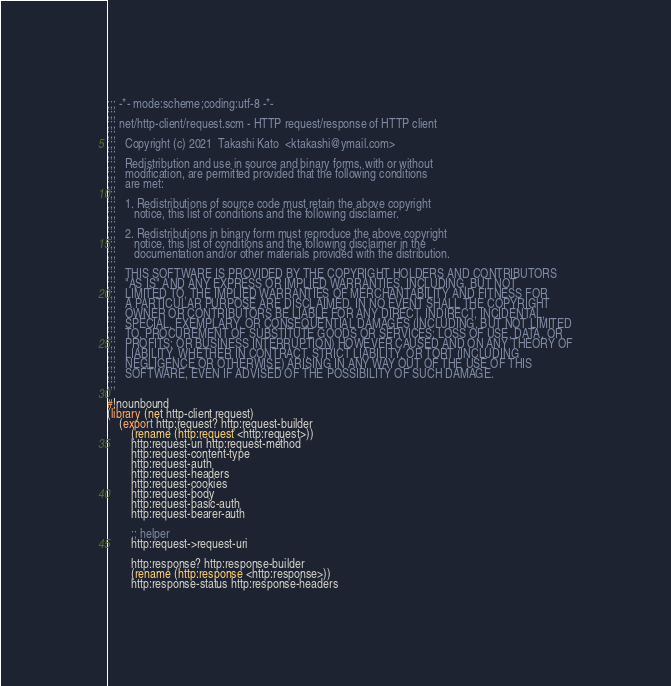<code> <loc_0><loc_0><loc_500><loc_500><_Scheme_>;;; -*- mode:scheme;coding:utf-8 -*-
;;;
;;; net/http-client/request.scm - HTTP request/response of HTTP client
;;;  
;;;   Copyright (c) 2021  Takashi Kato  <ktakashi@ymail.com>
;;;   
;;;   Redistribution and use in source and binary forms, with or without
;;;   modification, are permitted provided that the following conditions
;;;   are met:
;;;   
;;;   1. Redistributions of source code must retain the above copyright
;;;      notice, this list of conditions and the following disclaimer.
;;;  
;;;   2. Redistributions in binary form must reproduce the above copyright
;;;      notice, this list of conditions and the following disclaimer in the
;;;      documentation and/or other materials provided with the distribution.
;;;  
;;;   THIS SOFTWARE IS PROVIDED BY THE COPYRIGHT HOLDERS AND CONTRIBUTORS
;;;   "AS IS" AND ANY EXPRESS OR IMPLIED WARRANTIES, INCLUDING, BUT NOT
;;;   LIMITED TO, THE IMPLIED WARRANTIES OF MERCHANTABILITY AND FITNESS FOR
;;;   A PARTICULAR PURPOSE ARE DISCLAIMED. IN NO EVENT SHALL THE COPYRIGHT
;;;   OWNER OR CONTRIBUTORS BE LIABLE FOR ANY DIRECT, INDIRECT, INCIDENTAL,
;;;   SPECIAL, EXEMPLARY, OR CONSEQUENTIAL DAMAGES (INCLUDING, BUT NOT LIMITED
;;;   TO, PROCUREMENT OF SUBSTITUTE GOODS OR SERVICES; LOSS OF USE, DATA, OR
;;;   PROFITS; OR BUSINESS INTERRUPTION) HOWEVER CAUSED AND ON ANY THEORY OF
;;;   LIABILITY, WHETHER IN CONTRACT, STRICT LIABILITY, OR TORT (INCLUDING
;;;   NEGLIGENCE OR OTHERWISE) ARISING IN ANY WAY OUT OF THE USE OF THIS
;;;   SOFTWARE, EVEN IF ADVISED OF THE POSSIBILITY OF SUCH DAMAGE.
;;;  

#!nounbound
(library (net http-client request)
    (export http:request? http:request-builder
	    (rename (http:request <http:request>))
	    http:request-uri http:request-method
	    http:request-content-type
	    http:request-auth
	    http:request-headers
	    http:request-cookies
	    http:request-body
	    http:request-basic-auth
	    http:request-bearer-auth
	    
	    ;; helper
	    http:request->request-uri

	    http:response? http:response-builder
	    (rename (http:response <http:response>))
	    http:response-status http:response-headers</code> 